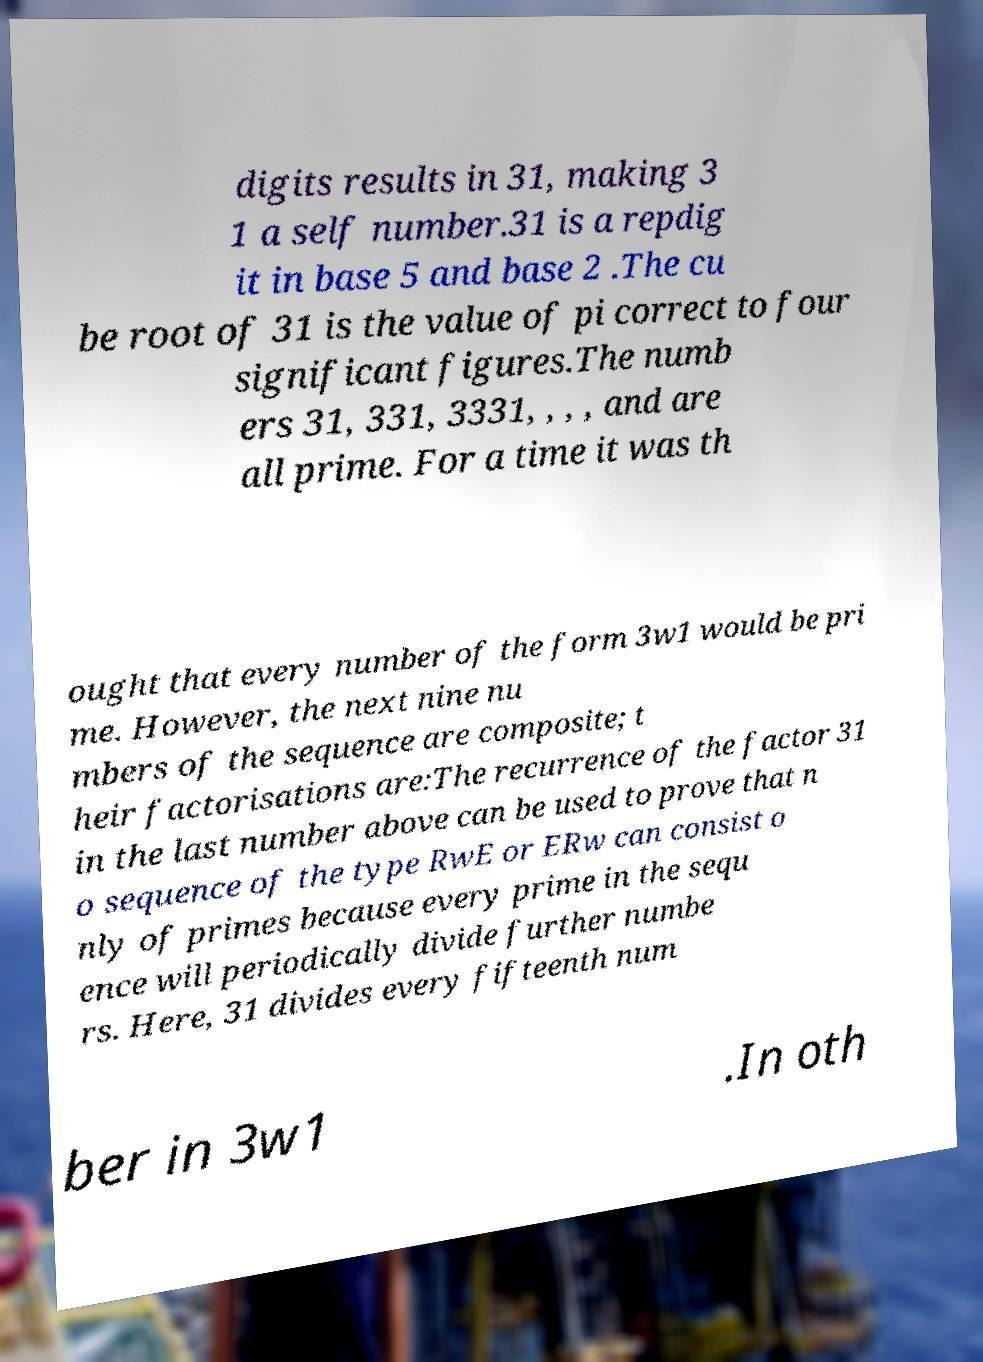For documentation purposes, I need the text within this image transcribed. Could you provide that? digits results in 31, making 3 1 a self number.31 is a repdig it in base 5 and base 2 .The cu be root of 31 is the value of pi correct to four significant figures.The numb ers 31, 331, 3331, , , , and are all prime. For a time it was th ought that every number of the form 3w1 would be pri me. However, the next nine nu mbers of the sequence are composite; t heir factorisations are:The recurrence of the factor 31 in the last number above can be used to prove that n o sequence of the type RwE or ERw can consist o nly of primes because every prime in the sequ ence will periodically divide further numbe rs. Here, 31 divides every fifteenth num ber in 3w1 .In oth 